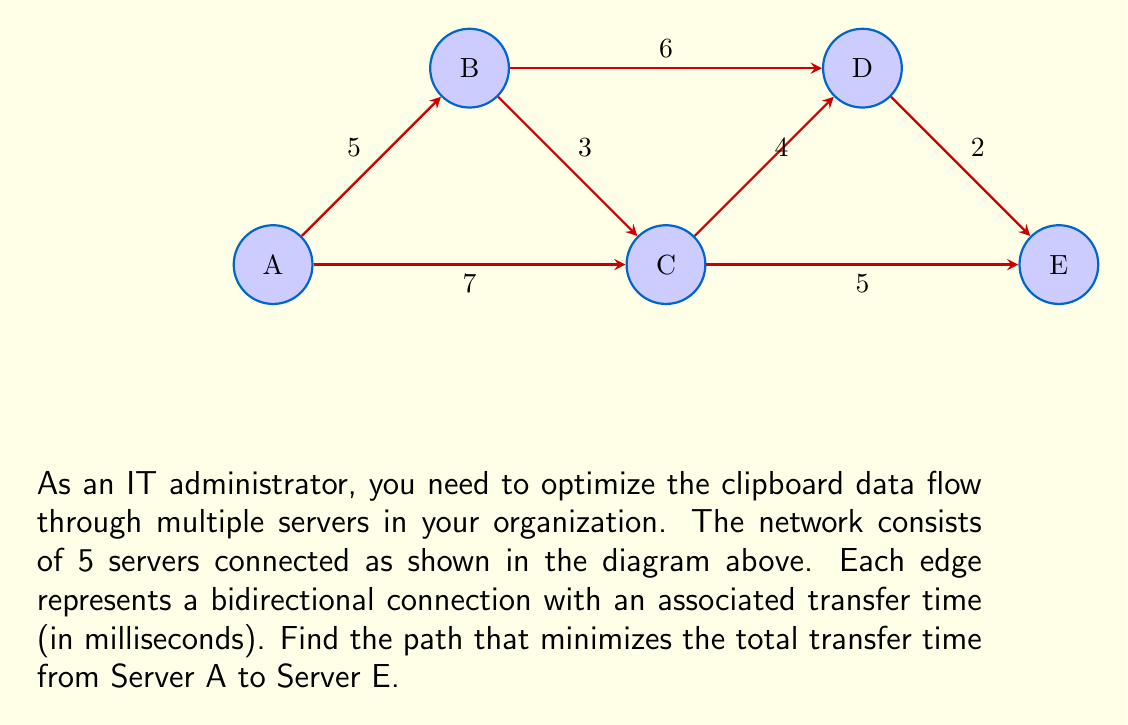Provide a solution to this math problem. To solve this problem, we need to use the concept of finding the shortest path in a weighted graph. We can use Dijkstra's algorithm to find the optimal path from Server A to Server E.

Step 1: Initialize distances
Set the distance to A as 0 and all other distances as infinity.
$d(A) = 0$, $d(B) = d(C) = d(D) = d(E) = \infty$

Step 2: Update distances for neighbors of A
$d(B) = \min(d(B), d(A) + 5) = 5$
$d(C) = \min(d(C), d(A) + 7) = 7$

Step 3: Select the unvisited node with the smallest distance (B)
Update distances for neighbors of B:
$d(C) = \min(d(C), d(B) + 3) = \min(7, 8) = 7$
$d(D) = \min(d(D), d(B) + 6) = 11$

Step 4: Select the unvisited node with the smallest distance (C)
Update distances for neighbors of C:
$d(D) = \min(d(D), d(C) + 4) = \min(11, 11) = 11$
$d(E) = \min(d(E), d(C) + 5) = 12$

Step 5: Select the unvisited node with the smallest distance (D)
Update distances for neighbors of D:
$d(E) = \min(d(E), d(D) + 2) = \min(12, 13) = 12$

Step 6: Select the last unvisited node (E)
All nodes have been visited, and the shortest path to E has been found.

The optimal path is A → C → E with a total transfer time of 12 ms.
Answer: A → C → E, 12 ms 